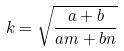<formula> <loc_0><loc_0><loc_500><loc_500>k = \sqrt { \frac { a + b } { a m + b n } }</formula> 